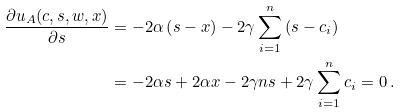Convert formula to latex. <formula><loc_0><loc_0><loc_500><loc_500>\frac { \partial u _ { A } ( c , s , w , x ) } { \partial s } & = - 2 \alpha \left ( s - x \right ) - 2 \gamma \sum _ { i = 1 } ^ { n } \left ( s - c _ { i } \right ) \\ & = - 2 \alpha s + 2 \alpha x - 2 \gamma n s + 2 \gamma \sum _ { i = 1 } ^ { n } c _ { i } = 0 \, .</formula> 